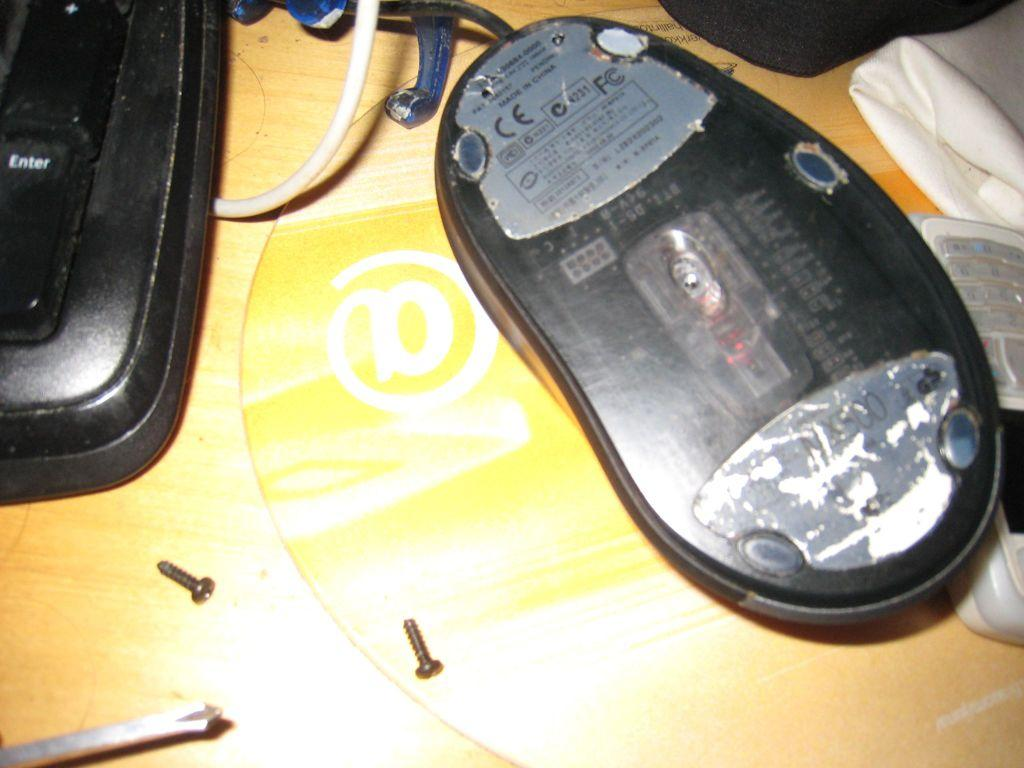What is on the wooden surface in the image? There is a mouse, a partially covered keyboard, screws, clothes, and a mobile phone on the wooden surface. Can you describe the mouse in the image? The mouse is on the wooden surface. What is the partially covered keyboard used for? The partially covered keyboard is likely used for typing on a computer or device. What might be used to fasten or attach objects in the image? The screws on the wooden surface might be used for fastening or attaching objects. What type of personal item is visible on the wooden surface? The mobile phone on the wooden surface is a personal item. How does the mouse express anger in the image? There is no indication of the mouse expressing anger in the image, as it is a still image and emotions cannot be conveyed through a mouse's body language. 